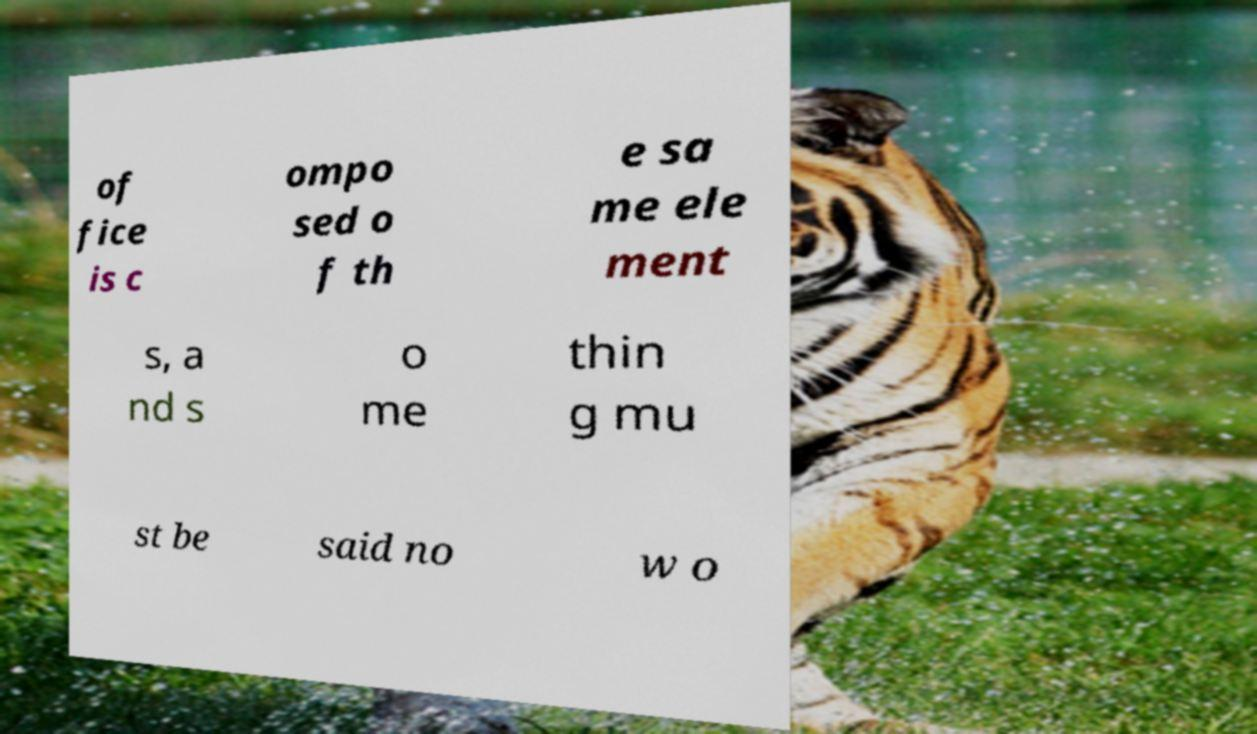Please read and relay the text visible in this image. What does it say? of fice is c ompo sed o f th e sa me ele ment s, a nd s o me thin g mu st be said no w o 